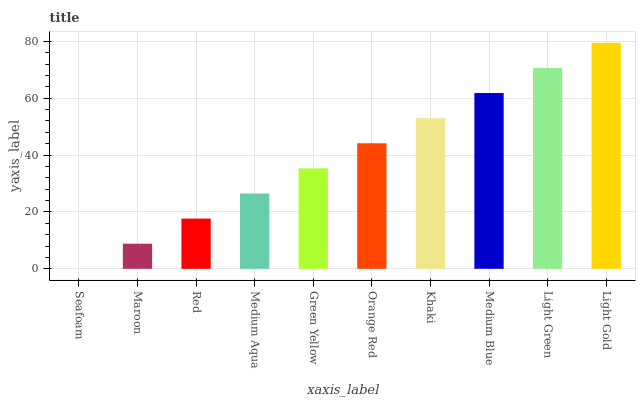Is Seafoam the minimum?
Answer yes or no. Yes. Is Light Gold the maximum?
Answer yes or no. Yes. Is Maroon the minimum?
Answer yes or no. No. Is Maroon the maximum?
Answer yes or no. No. Is Maroon greater than Seafoam?
Answer yes or no. Yes. Is Seafoam less than Maroon?
Answer yes or no. Yes. Is Seafoam greater than Maroon?
Answer yes or no. No. Is Maroon less than Seafoam?
Answer yes or no. No. Is Orange Red the high median?
Answer yes or no. Yes. Is Green Yellow the low median?
Answer yes or no. Yes. Is Maroon the high median?
Answer yes or no. No. Is Light Green the low median?
Answer yes or no. No. 